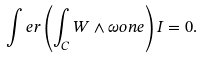<formula> <loc_0><loc_0><loc_500><loc_500>\int e r \left ( \int _ { C } W \wedge \omega o n e \right ) I = 0 .</formula> 